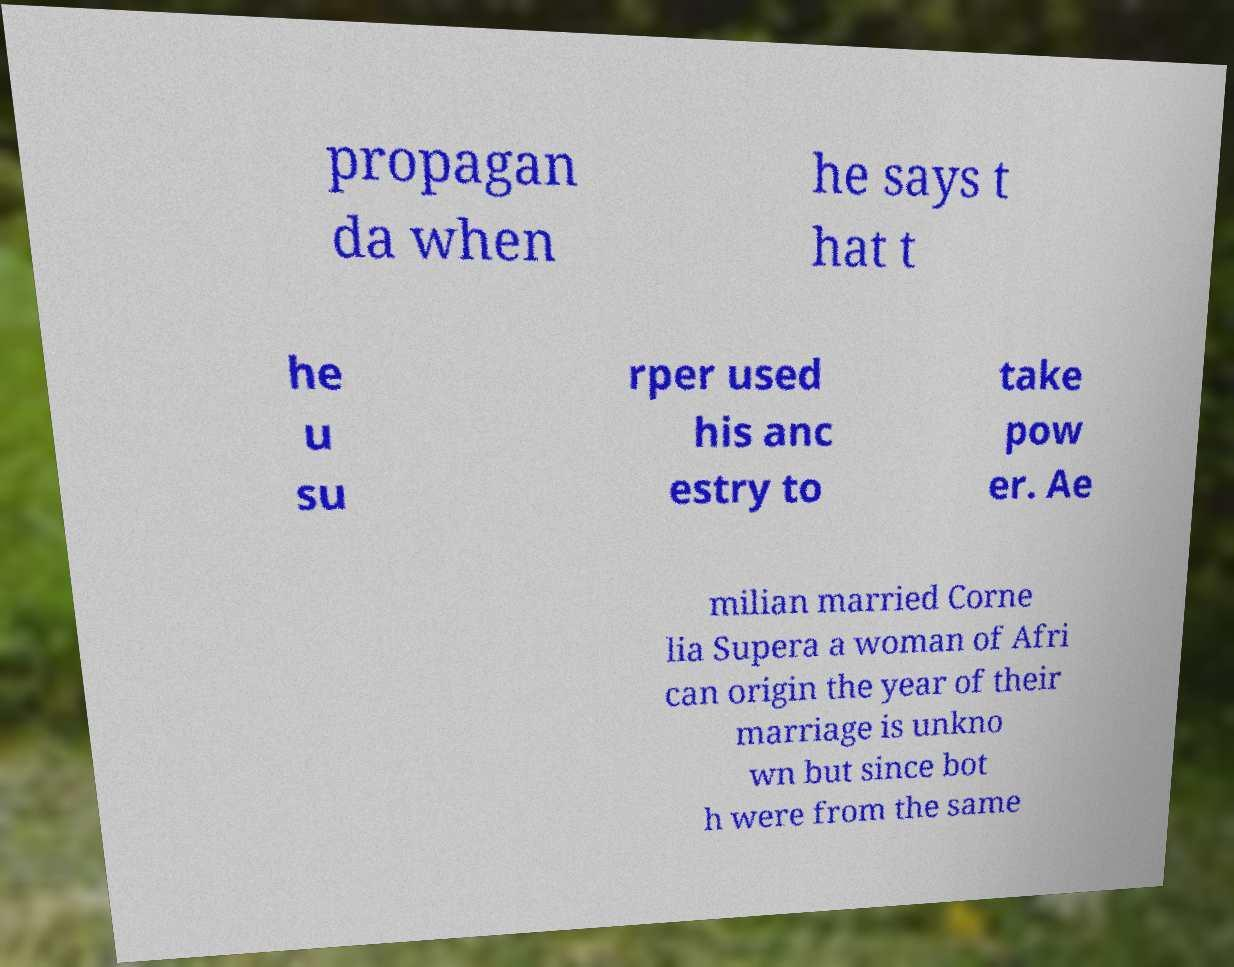Could you assist in decoding the text presented in this image and type it out clearly? propagan da when he says t hat t he u su rper used his anc estry to take pow er. Ae milian married Corne lia Supera a woman of Afri can origin the year of their marriage is unkno wn but since bot h were from the same 